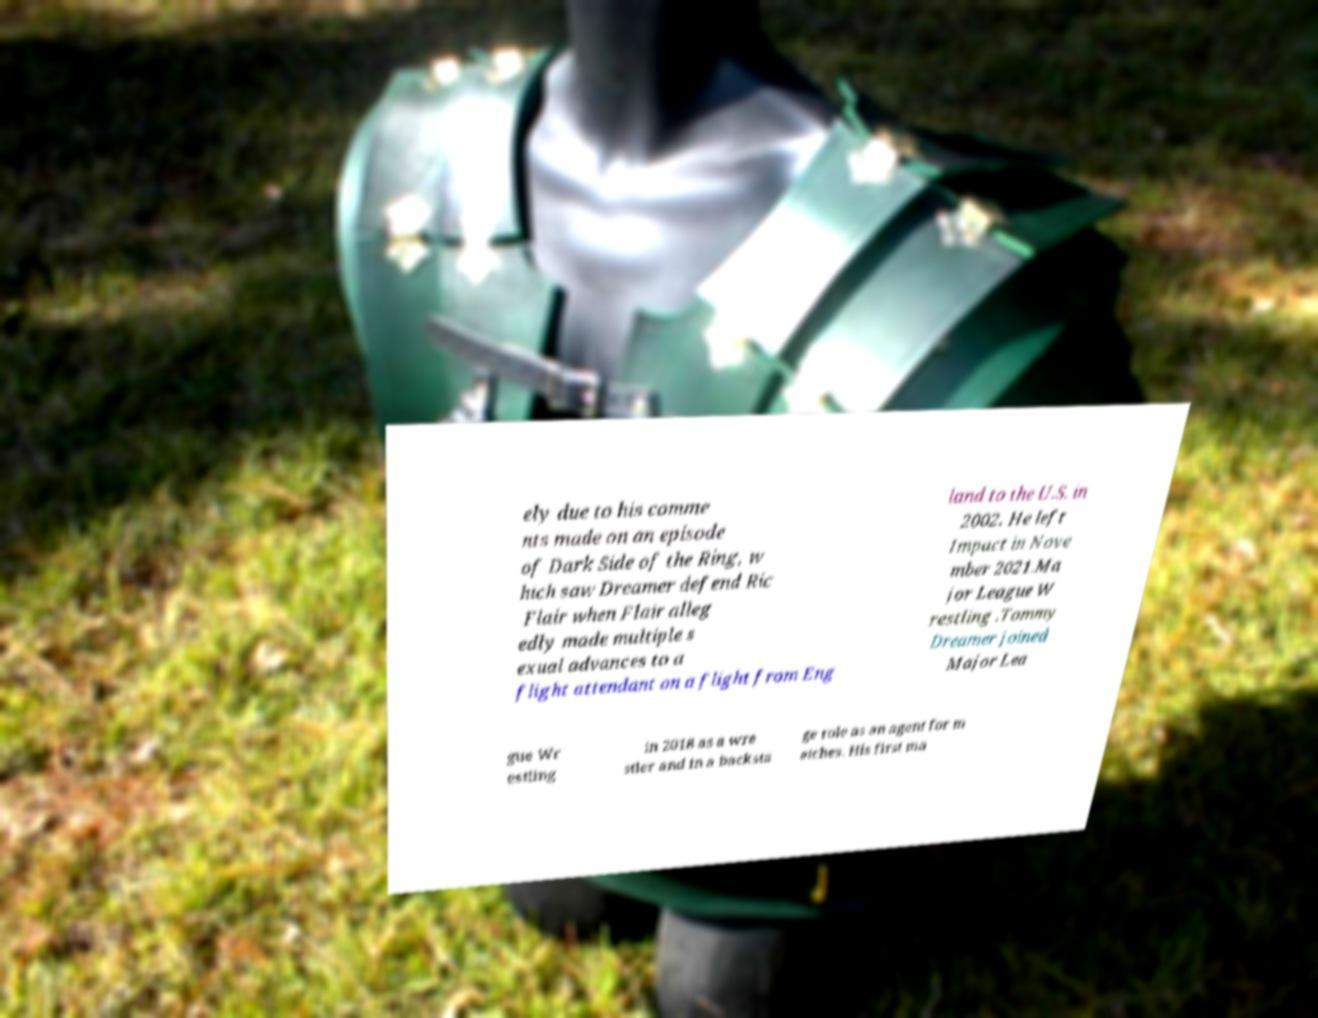Please identify and transcribe the text found in this image. ely due to his comme nts made on an episode of Dark Side of the Ring, w hich saw Dreamer defend Ric Flair when Flair alleg edly made multiple s exual advances to a flight attendant on a flight from Eng land to the U.S. in 2002. He left Impact in Nove mber 2021.Ma jor League W restling .Tommy Dreamer joined Major Lea gue Wr estling in 2018 as a wre stler and in a backsta ge role as an agent for m atches. His first ma 